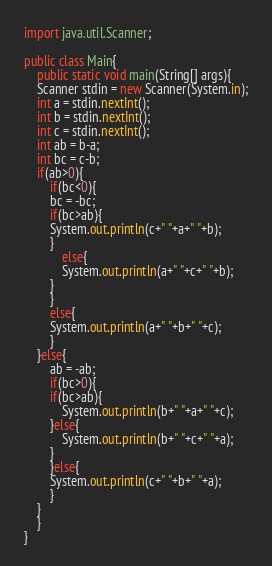Convert code to text. <code><loc_0><loc_0><loc_500><loc_500><_Java_>import java.util.Scanner;

public class Main{
    public static void main(String[] args){
	Scanner stdin = new Scanner(System.in);
	int a = stdin.nextInt();
	int b = stdin.nextInt();
	int c = stdin.nextInt();
	int ab = b-a;
	int bc = c-b;
	if(ab>0){
	    if(bc<0){
		bc = -bc;
		if(bc>ab){
		System.out.println(c+" "+a+" "+b);
		}
	        else{
		    System.out.println(a+" "+c+" "+b);
		}
	    }
	    else{
		System.out.println(a+" "+b+" "+c);
	    }
	}else{
	    ab = -ab;
	    if(bc>0){
		if(bc>ab){
		    System.out.println(b+" "+a+" "+c);
		}else{
		    System.out.println(b+" "+c+" "+a);
		}
	    }else{
		System.out.println(c+" "+b+" "+a);
	    }
	}
    }
}</code> 